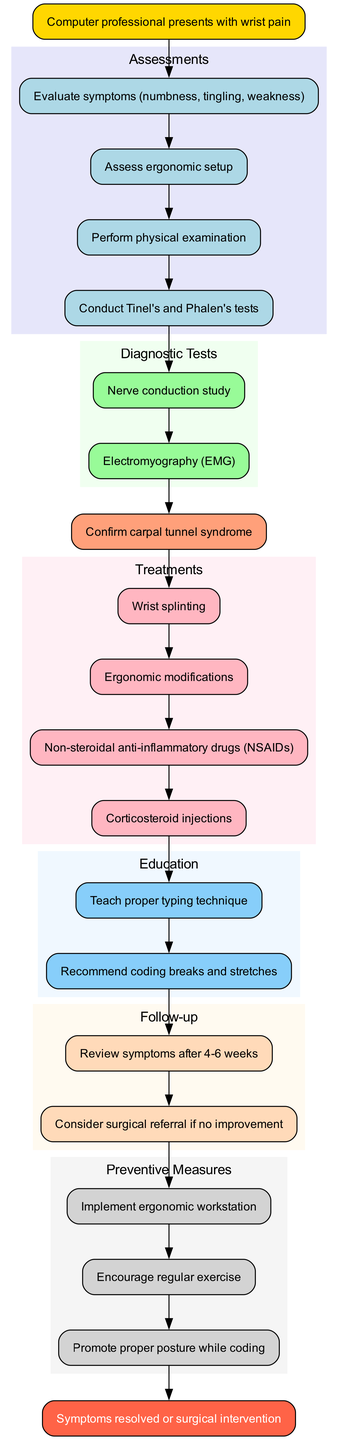What is the starting point of the clinical pathway? The starting point is clearly labeled as "Computer professional presents with wrist pain," marking the initial observation and entry into the pathway.
Answer: Computer professional presents with wrist pain How many assessments are conducted? By counting the listed assessments in the diagram, we find there are four assessments aimed at understanding the patient's condition through various evaluations.
Answer: 4 What is the conclusion of the pathway? The end node indicates two potential outcomes, which are either the resolution of symptoms or the need for surgical intervention, summarizing the possible conclusions after following the pathway.
Answer: Symptoms resolved or surgical intervention What is the first treatment listed? The first treatment node in the pathway, following the diagnosis, specifies "Wrist splinting," indicating the initial therapeutic approach taken after diagnosis.
Answer: Wrist splinting What educational advice is given after treatment? The diagram indicates that the educational advice following treatment includes two specific recommendations, with "Teach proper typing technique" being the first one listed.
Answer: Teach proper typing technique Which diagnostic test follows the physical examination? After the assessment, the first diagnostic test mentioned is the "Nerve conduction study," which typically follows an evaluation of symptoms and physical exams.
Answer: Nerve conduction study How many preventive measures are suggested in the pathway? By reviewing the preventive measures section in the diagram, we can see there are three distinct measures recommended to prevent future occurrences of carpal tunnel syndrome.
Answer: 3 What does the follow-up process involve after education? The follow-up process includes a review of symptoms after four to six weeks, which is vital for assessing the effectiveness of the treatments and further decision-making.
Answer: Review symptoms after 4-6 weeks What is the second follow-up action? The second follow-up action is a potential consideration for surgical referral if there is no improvement observed, indicating a critical decision point in the patient care process.
Answer: Consider surgical referral if no improvement 